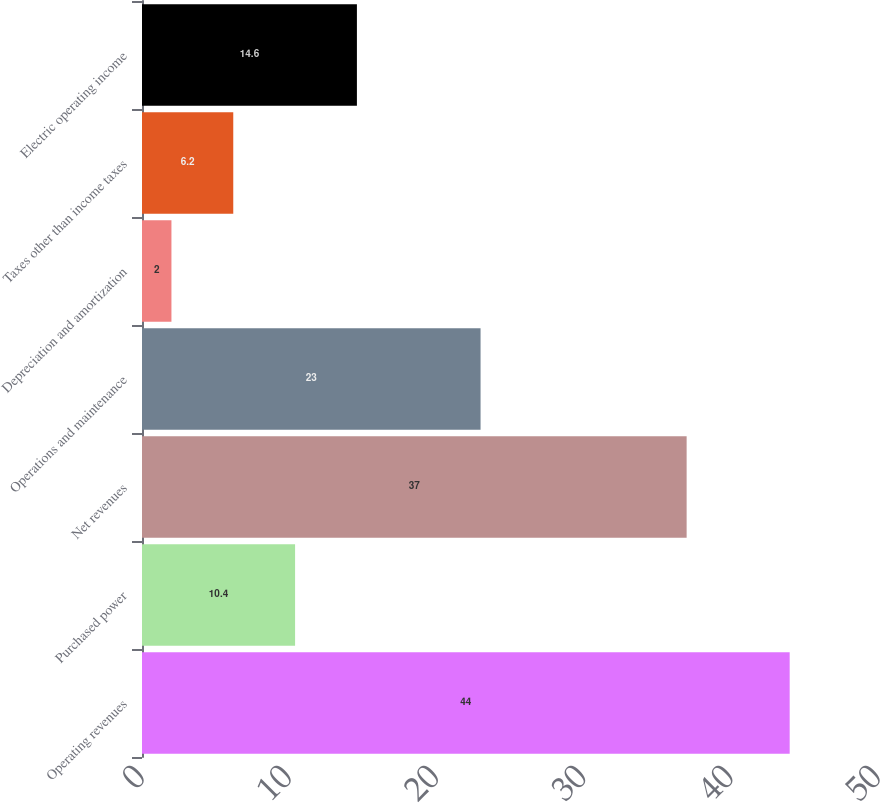<chart> <loc_0><loc_0><loc_500><loc_500><bar_chart><fcel>Operating revenues<fcel>Purchased power<fcel>Net revenues<fcel>Operations and maintenance<fcel>Depreciation and amortization<fcel>Taxes other than income taxes<fcel>Electric operating income<nl><fcel>44<fcel>10.4<fcel>37<fcel>23<fcel>2<fcel>6.2<fcel>14.6<nl></chart> 